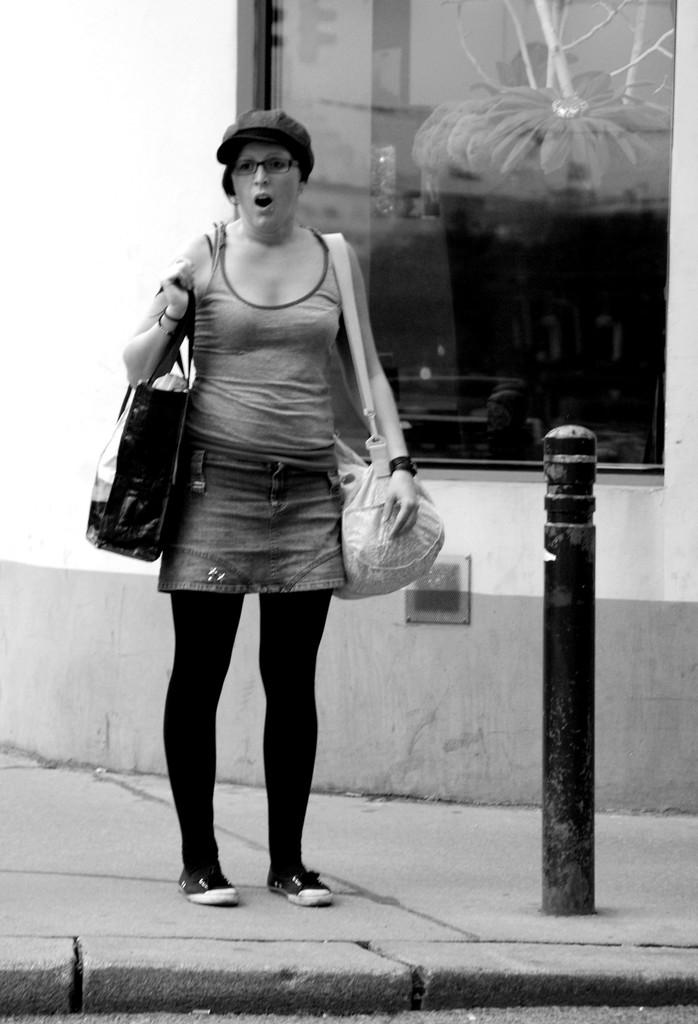Who is the main subject in the image? There is a woman in the image. What is the woman doing in the image? The woman is standing on a footpath and holding two bags. What can be seen on the right side of the image? There is a glass wall on the right side of the image. What is the color scheme of the image? The image is in black and white color. What type of error can be seen on the woman's dinner plate in the image? There is no dinner plate or any error present in the image. What is the title of the image? The image does not have a title, as it is a photograph or illustration and not a piece of artwork with a specific title. 